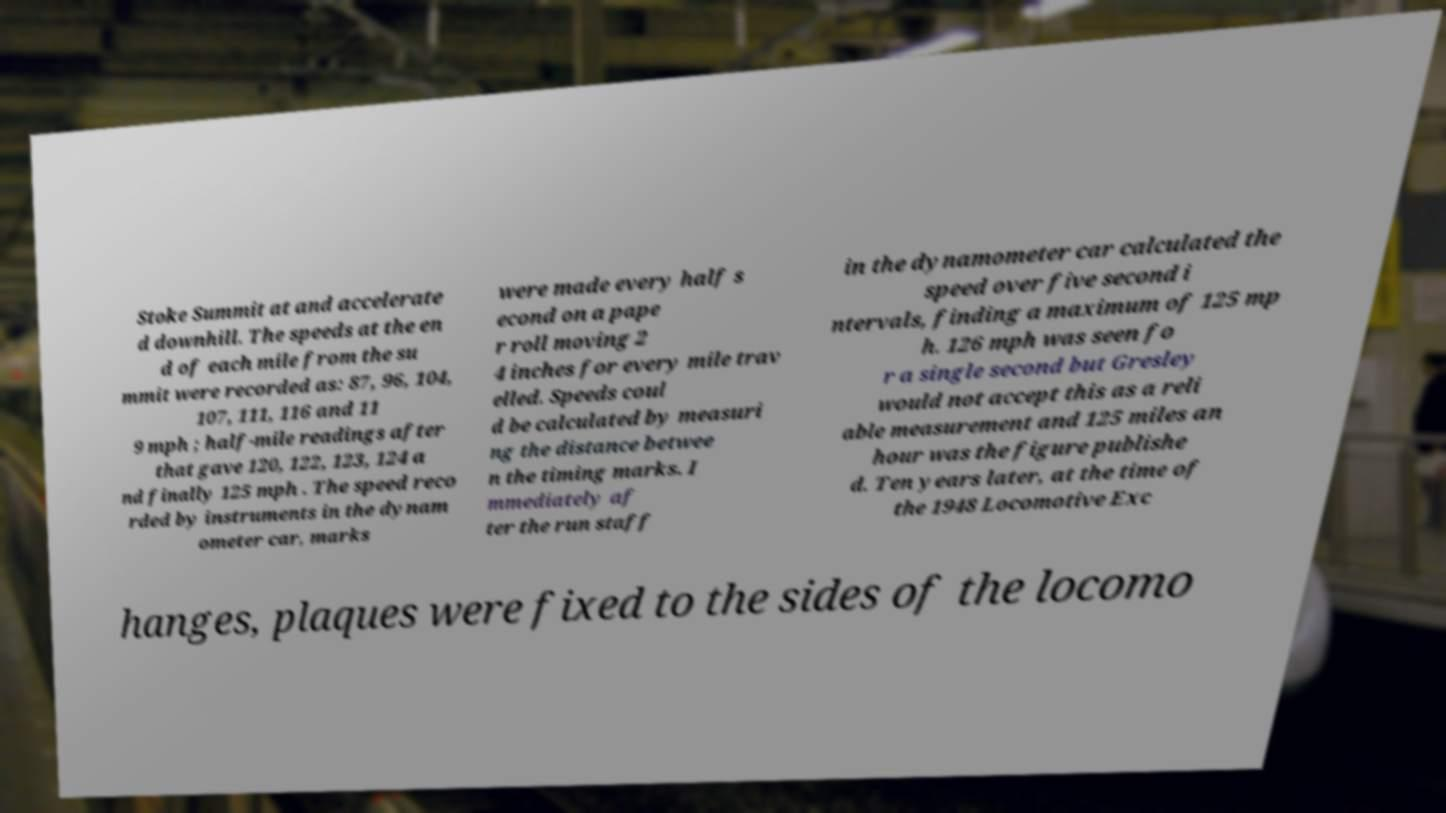Please identify and transcribe the text found in this image. Stoke Summit at and accelerate d downhill. The speeds at the en d of each mile from the su mmit were recorded as: 87, 96, 104, 107, 111, 116 and 11 9 mph ; half-mile readings after that gave 120, 122, 123, 124 a nd finally 125 mph . The speed reco rded by instruments in the dynam ometer car, marks were made every half s econd on a pape r roll moving 2 4 inches for every mile trav elled. Speeds coul d be calculated by measuri ng the distance betwee n the timing marks. I mmediately af ter the run staff in the dynamometer car calculated the speed over five second i ntervals, finding a maximum of 125 mp h. 126 mph was seen fo r a single second but Gresley would not accept this as a reli able measurement and 125 miles an hour was the figure publishe d. Ten years later, at the time of the 1948 Locomotive Exc hanges, plaques were fixed to the sides of the locomo 